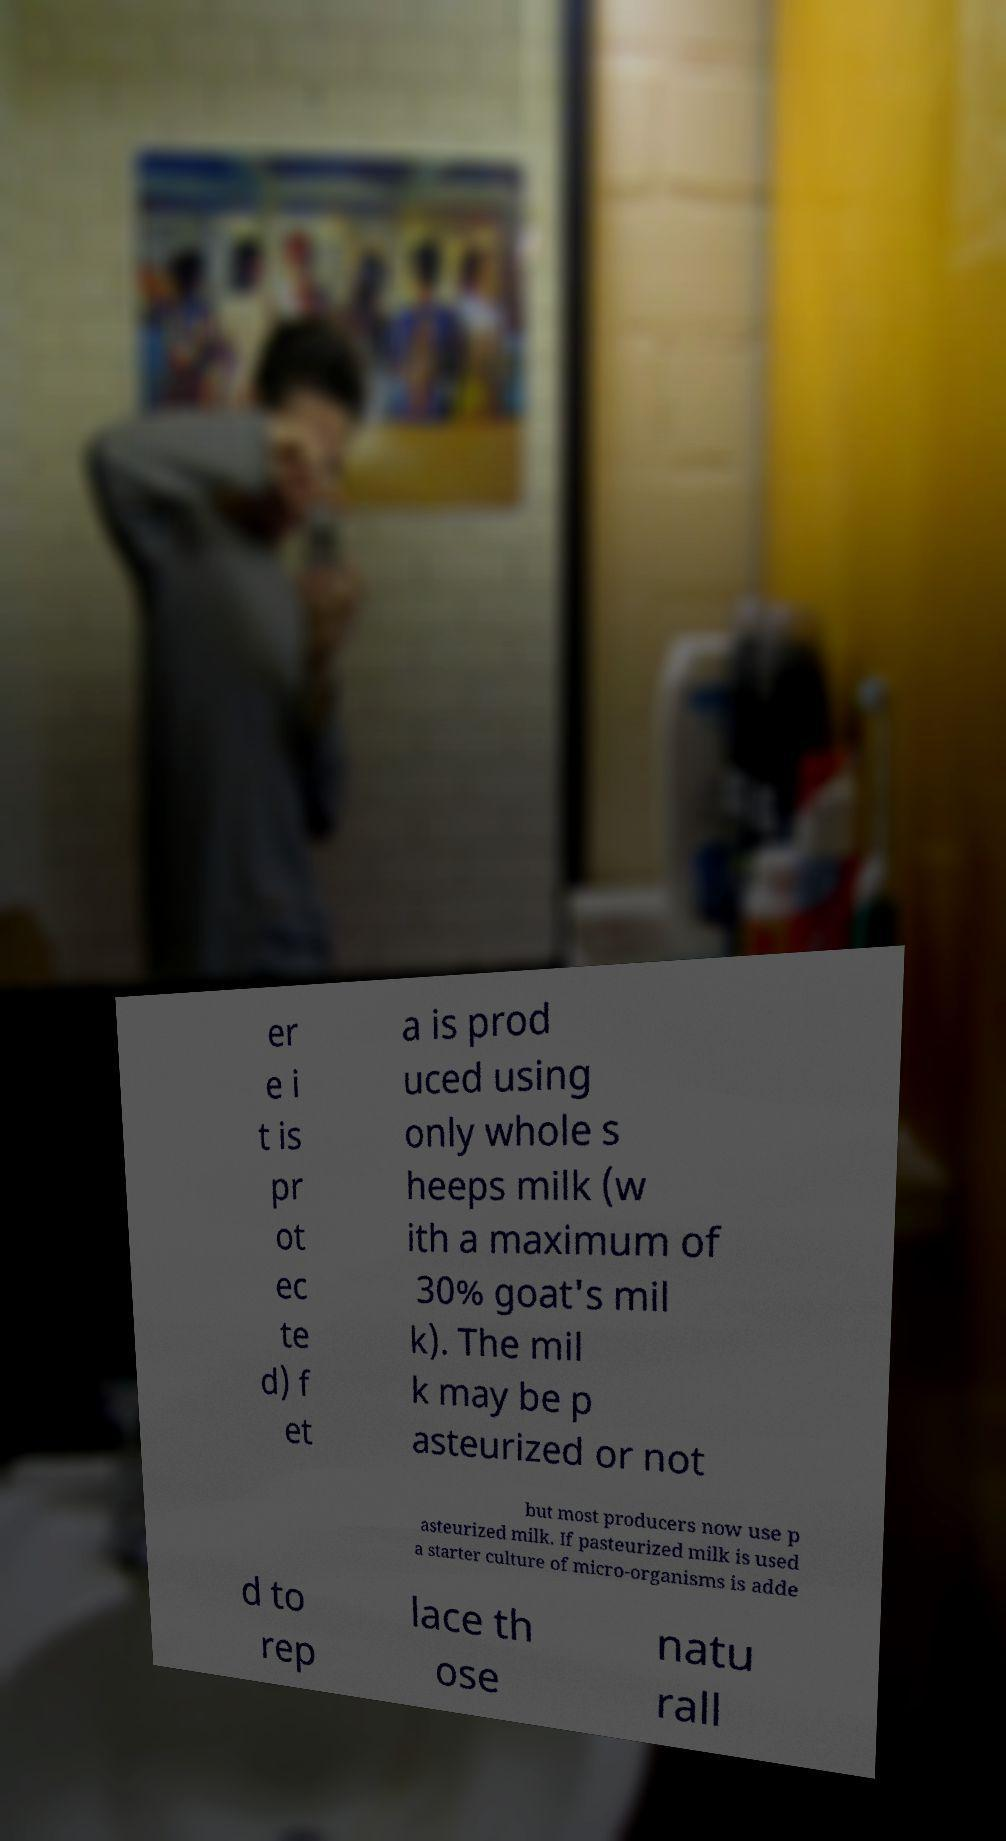Please read and relay the text visible in this image. What does it say? er e i t is pr ot ec te d) f et a is prod uced using only whole s heeps milk (w ith a maximum of 30% goat's mil k). The mil k may be p asteurized or not but most producers now use p asteurized milk. If pasteurized milk is used a starter culture of micro-organisms is adde d to rep lace th ose natu rall 